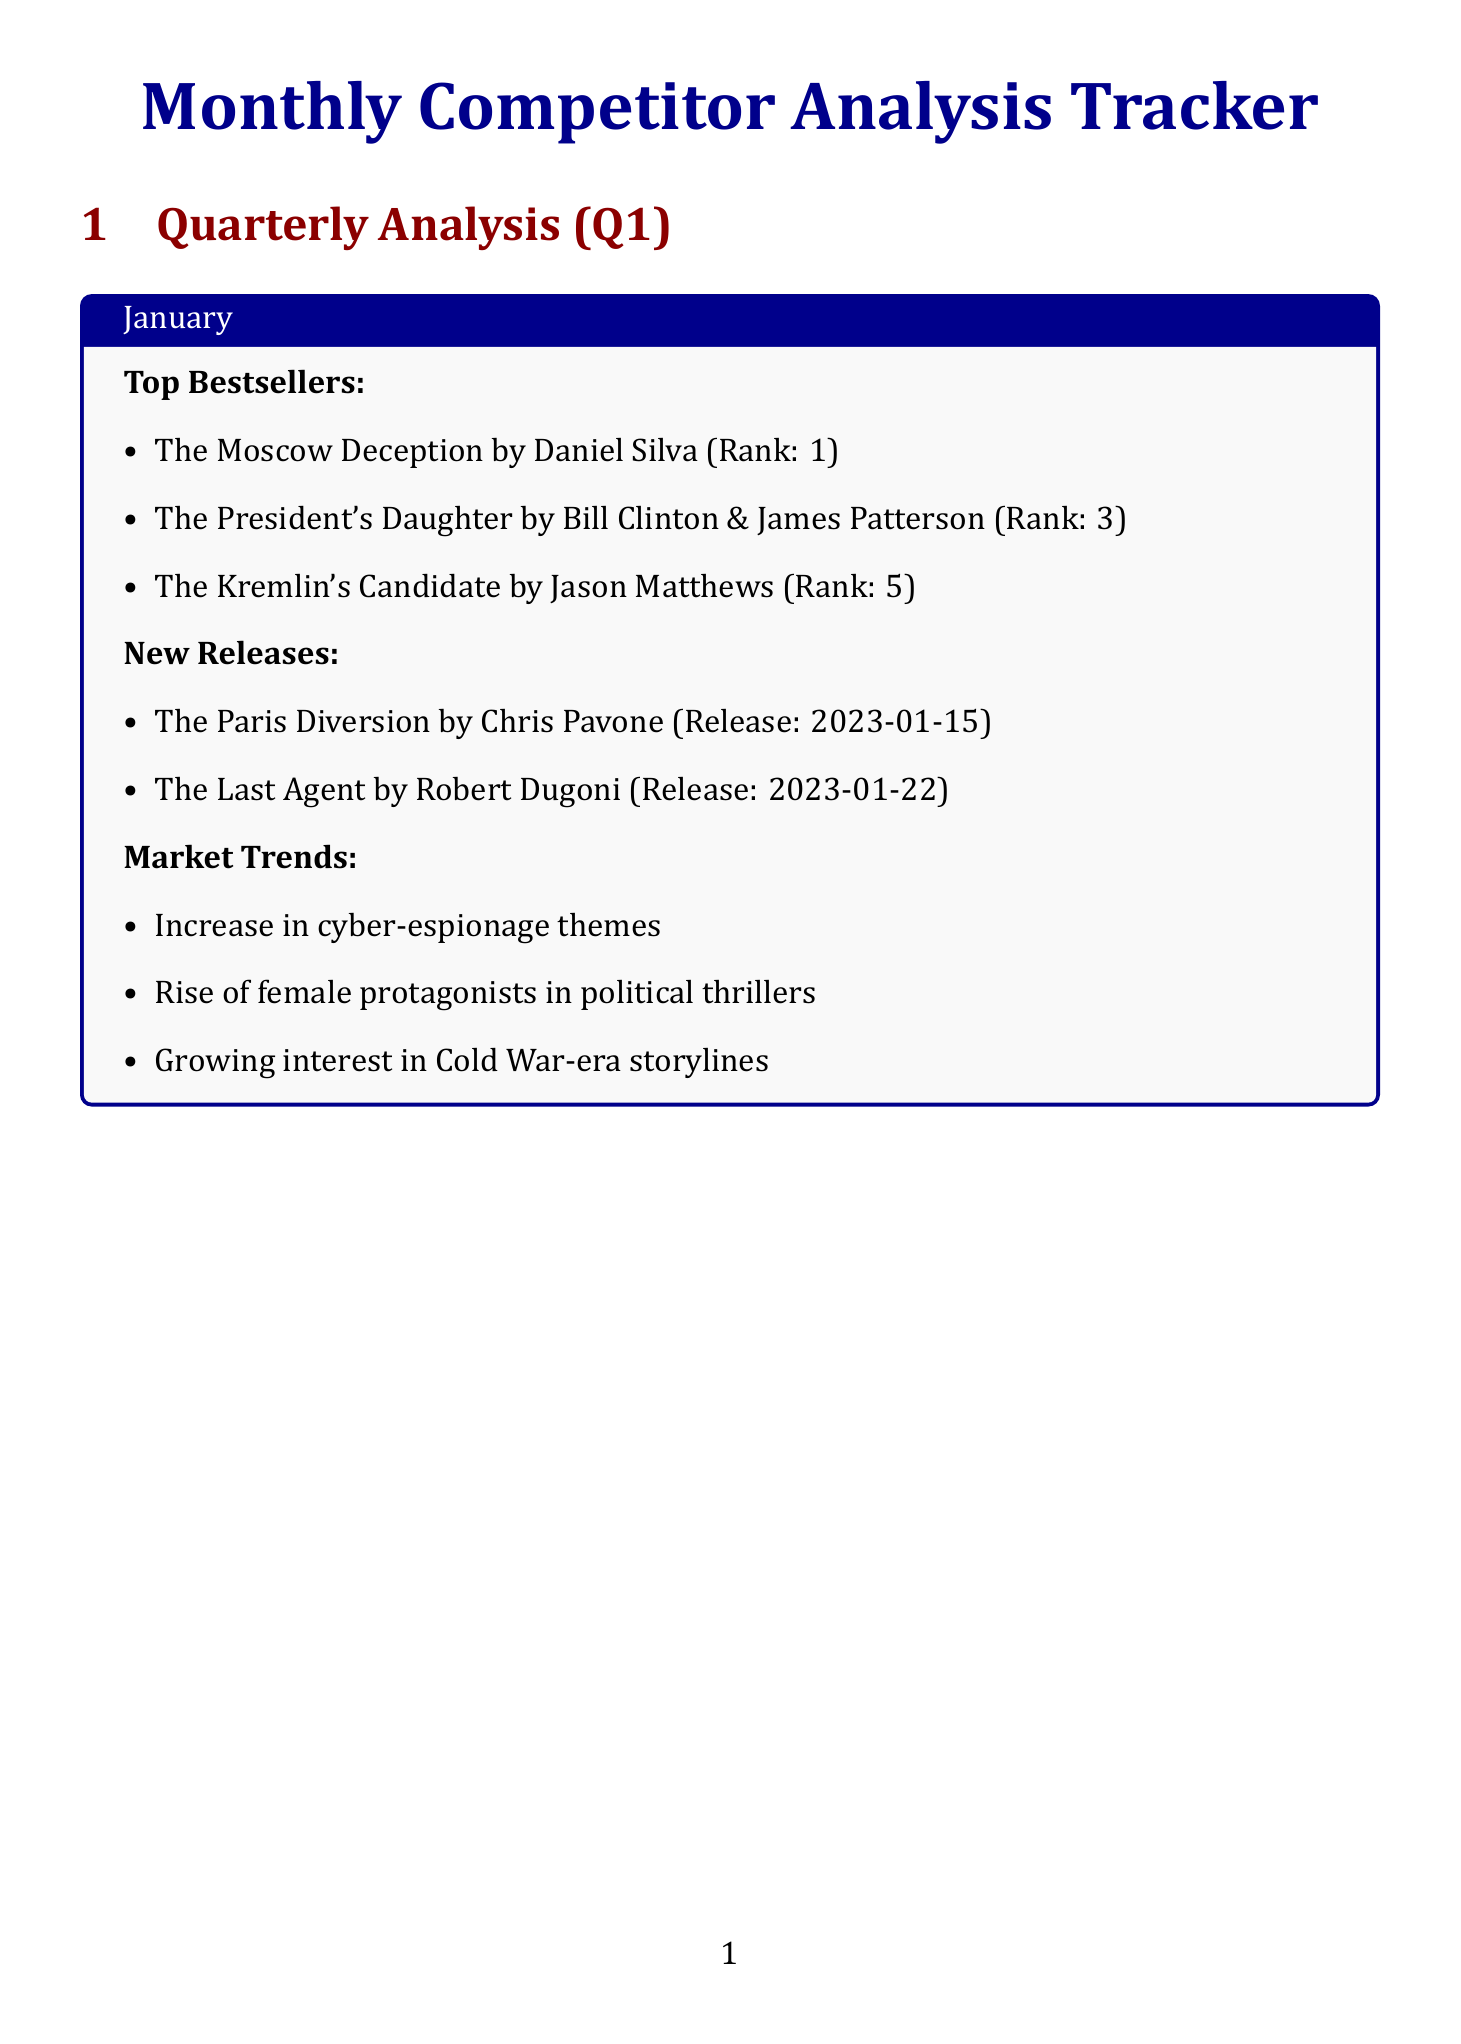what is the title of the top bestseller in January? The title of the top bestseller in January is the first item listed under top bestsellers for that month.
Answer: The Moscow Deception who is the author of "The Terminal List"? The author of "The Terminal List" is found in the February section under top bestsellers.
Answer: Jack Carr what are market trends mentioned in February? Market trends are listed in each month's section, specifically for February.
Answer: Increased focus on domestic terrorism plots when is the release date for "The Devil's Hand"? The release date is provided in the new releases section for March, associated with the book title.
Answer: 2023-03-08 what is Daniel Silva's average rank among key competitors? The average rank for Daniel Silva is available in the key competitors section of the document.
Answer: 1.3 which publisher is associated with "The Kaiser's Web"? The publisher of "The Kaiser's Web" can be found next to the book title in the new releases section for February.
Answer: Minotaur Books how many upcoming industry events are listed? The document lists a certain number of events under the upcoming industry events section.
Answer: 3 which month features the rise of techno-thrillers as a market trend? The month with this specific market trend is detailed in the relevant section for that month.
Answer: March who is the publisher of "The New Girl"? The publisher of "The New Girl" is indicated next to the author in the February bestsellers section.
Answer: HarperCollins 